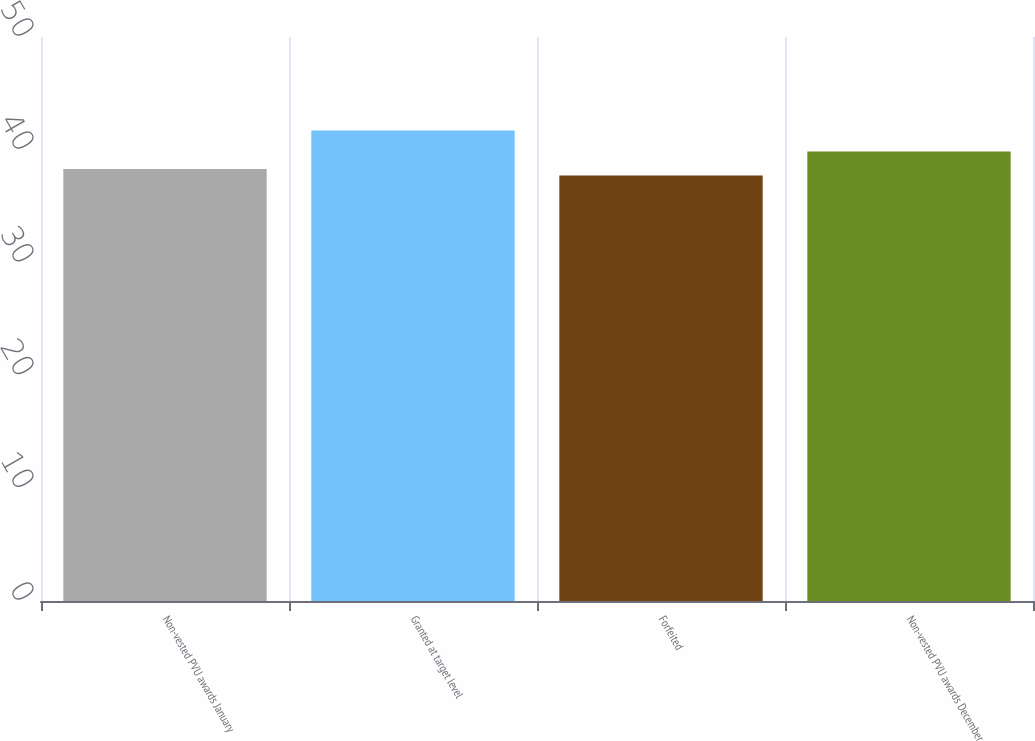<chart> <loc_0><loc_0><loc_500><loc_500><bar_chart><fcel>Non-vested PVU awards January<fcel>Granted at target level<fcel>Forfeited<fcel>Non-vested PVU awards December<nl><fcel>38.29<fcel>41.7<fcel>37.73<fcel>39.85<nl></chart> 